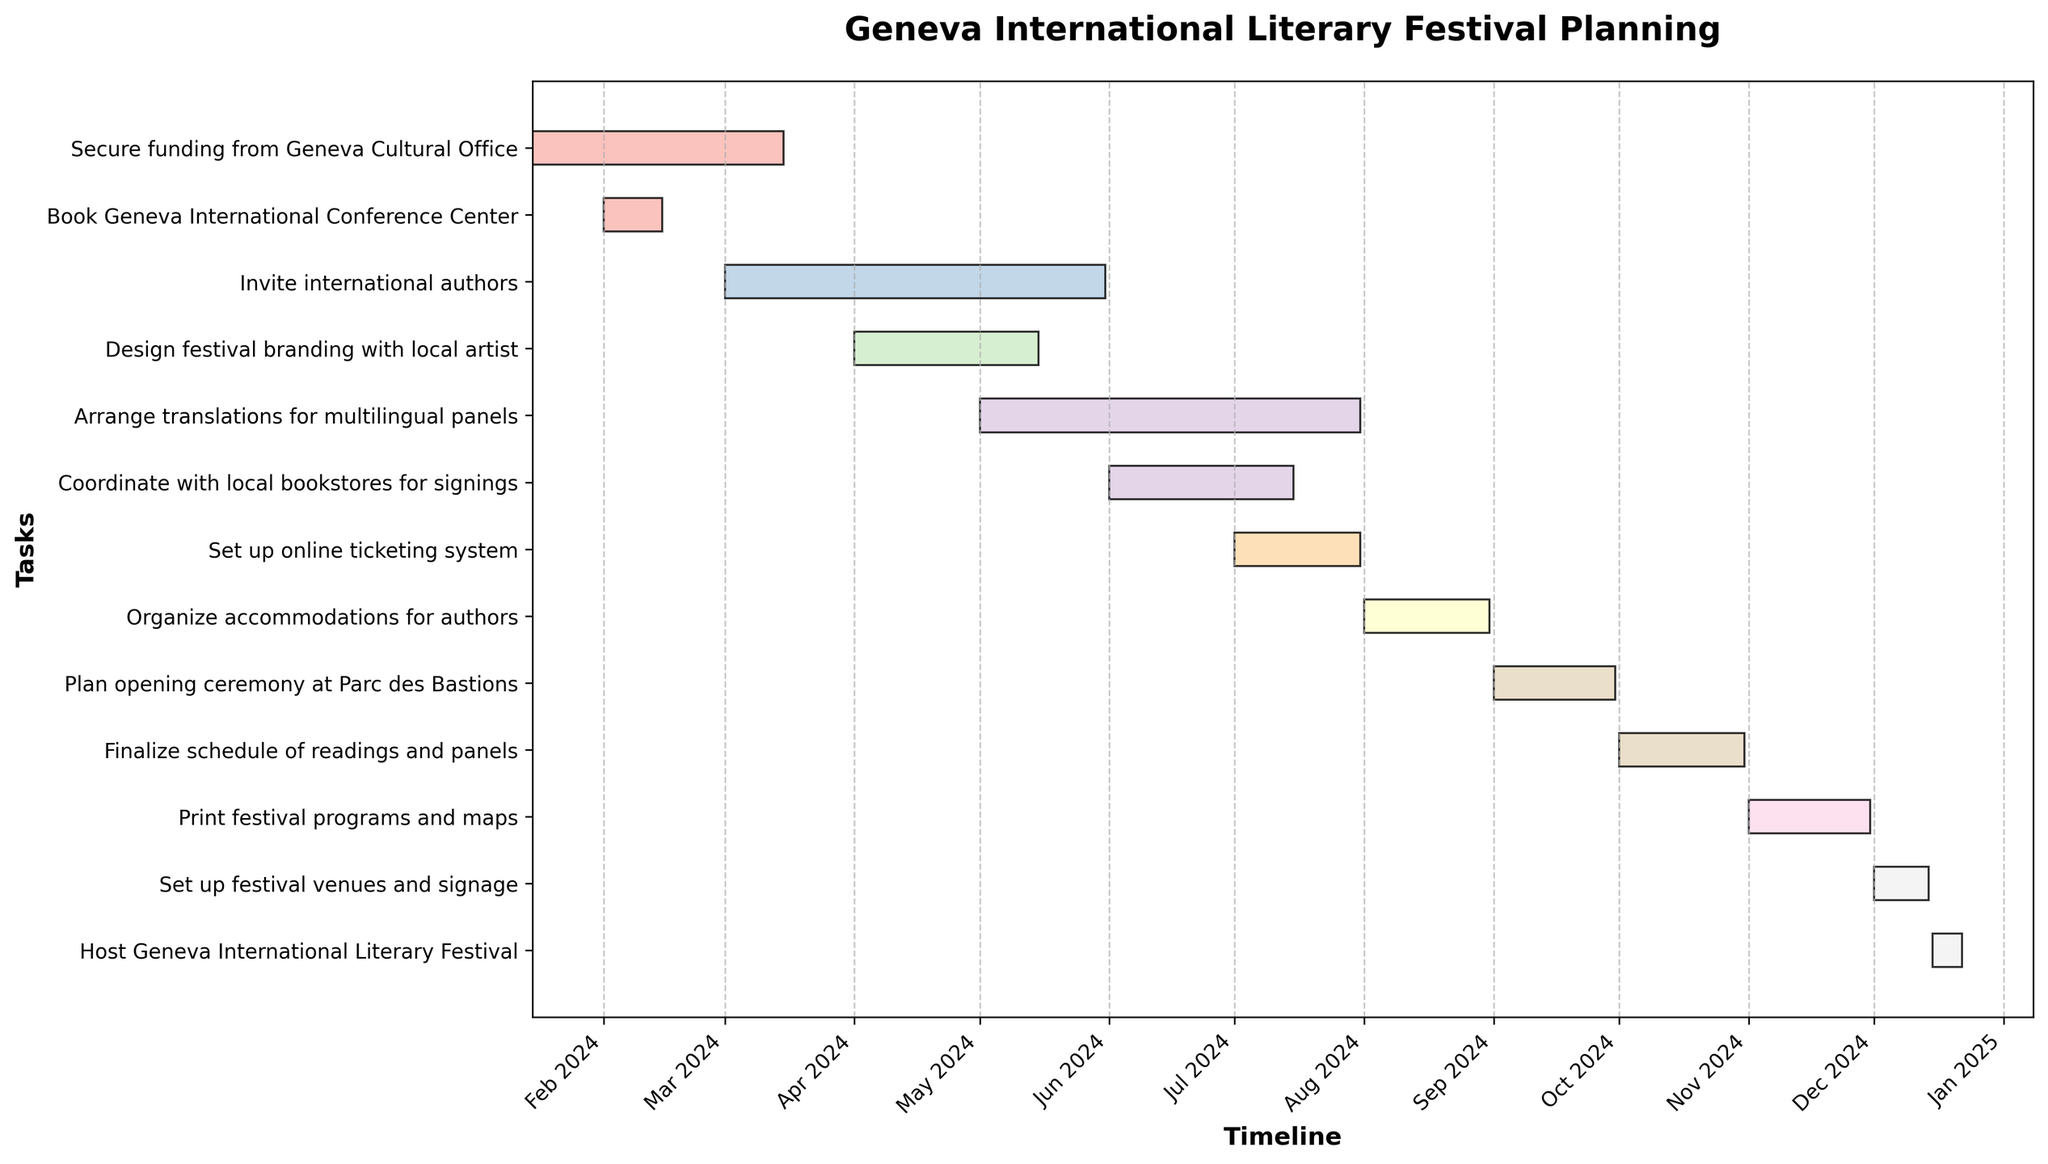What is the title of the Gantt chart? The title is usually found at the top of the chart, prominently displayed. In this case, it is "Geneva International Literary Festival Planning."
Answer: Geneva International Literary Festival Planning How many tasks are listed for organizing the festival? By counting the number of horizontal bars or entries, we can see there are 13 tasks listed.
Answer: 13 Which task starts the earliest and on what date does it begin? To find the earliest starting task, look for the task with the bar starting furthest to the left on the timeline. It is "Secure funding from Geneva Cultural Office" starting on 2024-01-15.
Answer: Secure funding from Geneva Cultural Office, 2024-01-15 Which tasks take place entirely in July 2024? Look for tasks with bars that start and end within the month of July 2024. "Set up online ticketing system" runs from 2024-07-01 to 2024-07-31.
Answer: Set up online ticketing system What is the duration of the "Invite international authors" task? The duration is given directly by the length of the bar. The task starts on 2024-03-01 and ends on 2024-05-31. The duration is 92 days.
Answer: 92 days Which task has the shortest duration and how long is it? The shortest duration corresponds to the shortest bar. "Book Geneva International Conference Center" runs from 2024-02-01 to 2024-02-15, lasting 14 days.
Answer: Book Geneva International Conference Center, 14 days Which tasks overlap in the month of May 2024? Tasks overlapping in May 2024 are those whose bars cover this period. "Invite international authors," "Design festival branding with local artist," and "Arrange translations for multilingual panels" overlap in May 2024.
Answer: Invite international authors, Design festival branding with local artist, Arrange translations for multilingual panels When does the task "Finalize schedule of readings and panels" start and what event is planned immediately after it? The start date is given by the bar's left point. It starts on 2024-10-01. The event following it is "Print festival programs and maps," which starts on 2024-11-01.
Answer: 2024-10-01, Print festival programs and maps What is the task that must be completed before the "Host Geneva International Literary Festival"? The task immediately preceding it is found by looking at the bar just before it on the timeline. "Set up festival venues and signage" is the task that must be completed before hosting the festival.
Answer: Set up festival venues and signage 